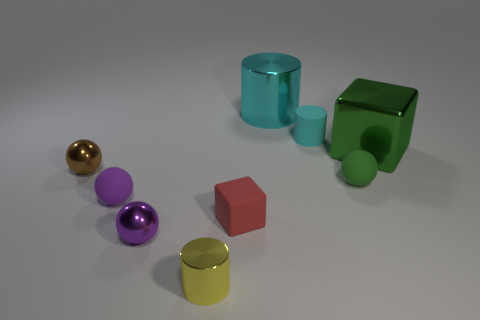Subtract all yellow blocks. How many purple balls are left? 2 Subtract all yellow metal cylinders. How many cylinders are left? 2 Subtract all brown balls. How many balls are left? 3 Subtract 1 cylinders. How many cylinders are left? 2 Subtract all gray balls. Subtract all red blocks. How many balls are left? 4 Add 1 brown shiny things. How many objects exist? 10 Subtract all cylinders. How many objects are left? 6 Add 1 big cylinders. How many big cylinders exist? 2 Subtract 1 red blocks. How many objects are left? 8 Subtract all big green metallic blocks. Subtract all large green blocks. How many objects are left? 7 